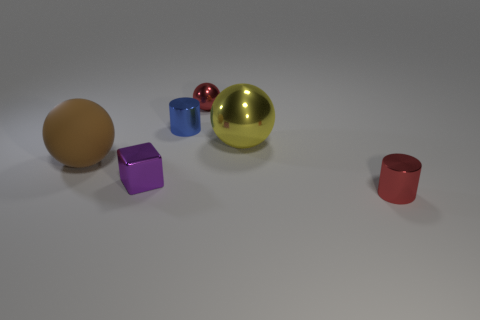What number of other things are there of the same shape as the brown matte object?
Your answer should be compact. 2. There is a small cylinder that is to the right of the big yellow metal object; is its color the same as the metallic cube that is on the right side of the brown rubber object?
Offer a terse response. No. There is a red thing in front of the small cylinder that is to the left of the tiny red object that is behind the large yellow metal sphere; how big is it?
Provide a short and direct response. Small. What is the shape of the metal thing that is behind the tiny purple thing and on the right side of the small shiny ball?
Keep it short and to the point. Sphere. Is the number of tiny red metal cylinders that are on the left side of the blue metallic object the same as the number of red metal cylinders that are left of the large brown ball?
Give a very brief answer. Yes. Is there a tiny red object that has the same material as the small red sphere?
Ensure brevity in your answer.  Yes. Do the small thing on the right side of the big yellow sphere and the blue object have the same material?
Keep it short and to the point. Yes. What size is the sphere that is both to the right of the tiny cube and in front of the small red metallic ball?
Ensure brevity in your answer.  Large. What is the color of the small ball?
Your response must be concise. Red. What number of tiny cylinders are there?
Offer a terse response. 2. 